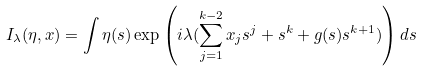Convert formula to latex. <formula><loc_0><loc_0><loc_500><loc_500>I _ { \lambda } ( \eta , x ) = \int \eta ( s ) \exp \left ( i \lambda ( \sum _ { j = 1 } ^ { k - 2 } x _ { j } s ^ { j } + s ^ { k } + g ( s ) s ^ { k + 1 } ) \right ) d s</formula> 